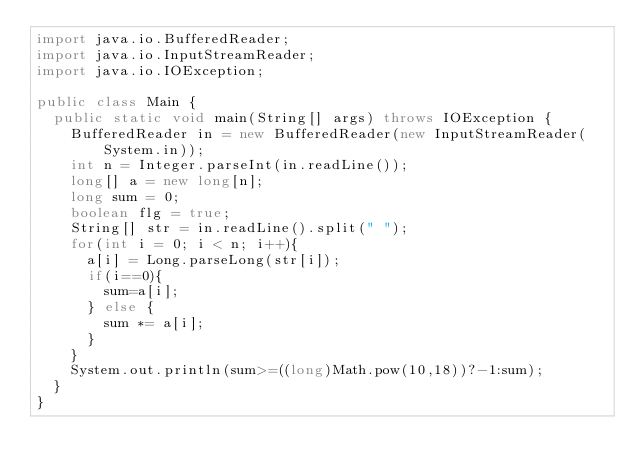Convert code to text. <code><loc_0><loc_0><loc_500><loc_500><_Java_>import java.io.BufferedReader;
import java.io.InputStreamReader;
import java.io.IOException;

public class Main {
  public static void main(String[] args) throws IOException {
    BufferedReader in = new BufferedReader(new InputStreamReader(System.in));
    int n = Integer.parseInt(in.readLine());
    long[] a = new long[n];
    long sum = 0;
    boolean flg = true;
    String[] str = in.readLine().split(" ");
    for(int i = 0; i < n; i++){
      a[i] = Long.parseLong(str[i]);
      if(i==0){
        sum=a[i];
      } else {
        sum *= a[i];
      }
    }
    System.out.println(sum>=((long)Math.pow(10,18))?-1:sum);
  }
}</code> 